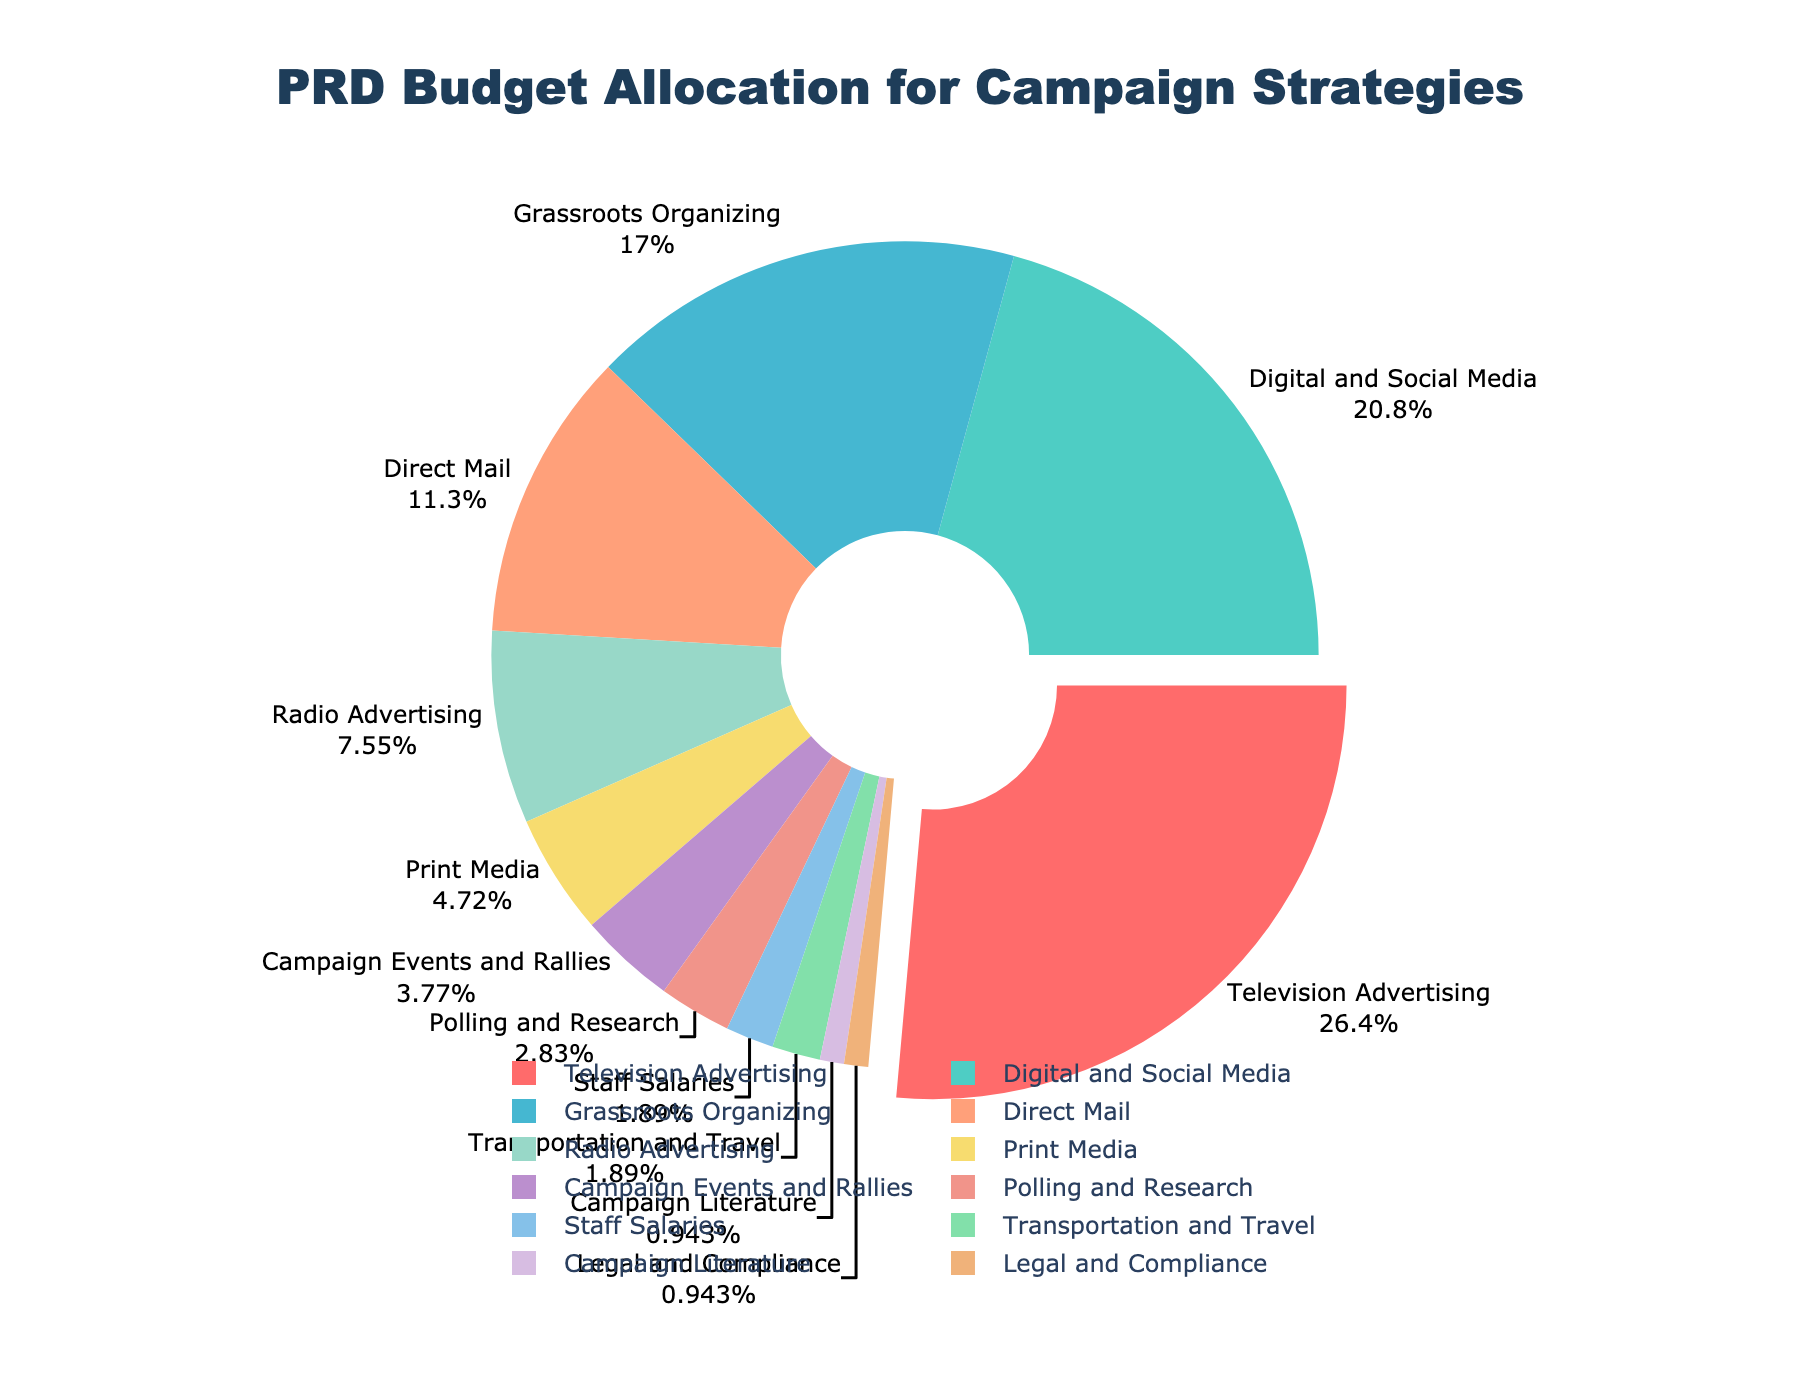Which campaign strategy has the highest budget allocation? The pie chart shows that "Television Advertising" has the largest slice pulled out from the center. This visual cue indicates that it has the highest budget allocation.
Answer: Television Advertising How much more budget is allocated to Digital and Social Media compared to Radio Advertising? Digital and Social Media has a budget allocation of 22%, while Radio Advertising has 8%. The difference between the two is 22% - 8% = 14%.
Answer: 14% What is the combined budget percentage for Grassroots Organizing, Direct Mail, and Campaign Events and Rallies? The budget percentages for Grassroots Organizing, Direct Mail, and Campaign Events and Rallies are 18%, 12%, and 4% respectively. The combined budget is 18% + 12% + 4% = 34%.
Answer: 34% How does the budget allocation for Staff Salaries compare to that for Transportation and Travel? Both Staff Salaries and Transportation and Travel have the same budget allocation of 2%, indicating they are equal.
Answer: Equal Which campaign strategy has the smallest budget allocation, and what is its percentage? The smallest slice on the pie chart is for Campaign Literature and Legal and Compliance, each with 1% of the budget allocation.
Answer: Campaign Literature and Legal and Compliance, 1% What is the difference in budget allocation between Print Media and Campaign Literature? Print Media has a budget allocation of 5% and Campaign Literature has 1%. The difference is 5% - 1% = 4%.
Answer: 4% Which campaign strategies together make up below 10% of the total budget allocation? Adding the percentages for Polling and Research (3%), Staff Salaries (2%), Transportation and Travel (2%), Campaign Literature (1%), and Legal and Compliance (1%) results in a total of 9%.
Answer: Polling and Research, Staff Salaries, Transportation and Travel, Campaign Literature, Legal and Compliance What is the total budget allocation for Television Advertising and Radio Advertising combined? The budget percentages for Television Advertising and Radio Advertising are 28% and 8%, respectively. Their combined total is 28% + 8% = 36%.
Answer: 36% If the pie chart were to be divided into three sections: Digital (including Digital and Social Media, Digital Mail, and Polling and Research), Traditional (including Television Advertising, Radio Advertising, Print Media), and Other (including everything else), which category would hold the largest share? Summing up the percentages: Digital = 22% + 12% + 3% = 37%, Traditional = 28% + 8% + 5% = 41%, Other = remaining percentages = 100% - (37% + 41%) = 22%. Traditional holds the largest share at 41%.
Answer: Traditional 